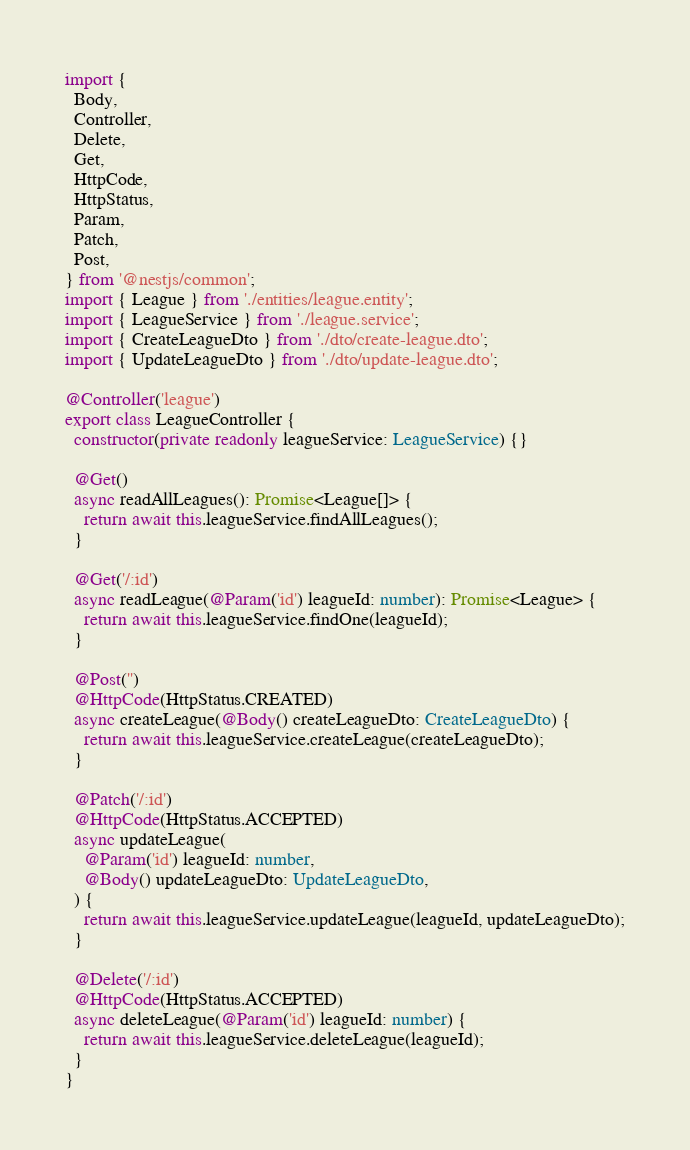<code> <loc_0><loc_0><loc_500><loc_500><_TypeScript_>import {
  Body,
  Controller,
  Delete,
  Get,
  HttpCode,
  HttpStatus,
  Param,
  Patch,
  Post,
} from '@nestjs/common';
import { League } from './entities/league.entity';
import { LeagueService } from './league.service';
import { CreateLeagueDto } from './dto/create-league.dto';
import { UpdateLeagueDto } from './dto/update-league.dto';

@Controller('league')
export class LeagueController {
  constructor(private readonly leagueService: LeagueService) {}

  @Get()
  async readAllLeagues(): Promise<League[]> {
    return await this.leagueService.findAllLeagues();
  }

  @Get('/:id')
  async readLeague(@Param('id') leagueId: number): Promise<League> {
    return await this.leagueService.findOne(leagueId);
  }

  @Post('')
  @HttpCode(HttpStatus.CREATED)
  async createLeague(@Body() createLeagueDto: CreateLeagueDto) {
    return await this.leagueService.createLeague(createLeagueDto);
  }

  @Patch('/:id')
  @HttpCode(HttpStatus.ACCEPTED)
  async updateLeague(
    @Param('id') leagueId: number,
    @Body() updateLeagueDto: UpdateLeagueDto,
  ) {
    return await this.leagueService.updateLeague(leagueId, updateLeagueDto);
  }

  @Delete('/:id')
  @HttpCode(HttpStatus.ACCEPTED)
  async deleteLeague(@Param('id') leagueId: number) {
    return await this.leagueService.deleteLeague(leagueId);
  }
}
</code> 